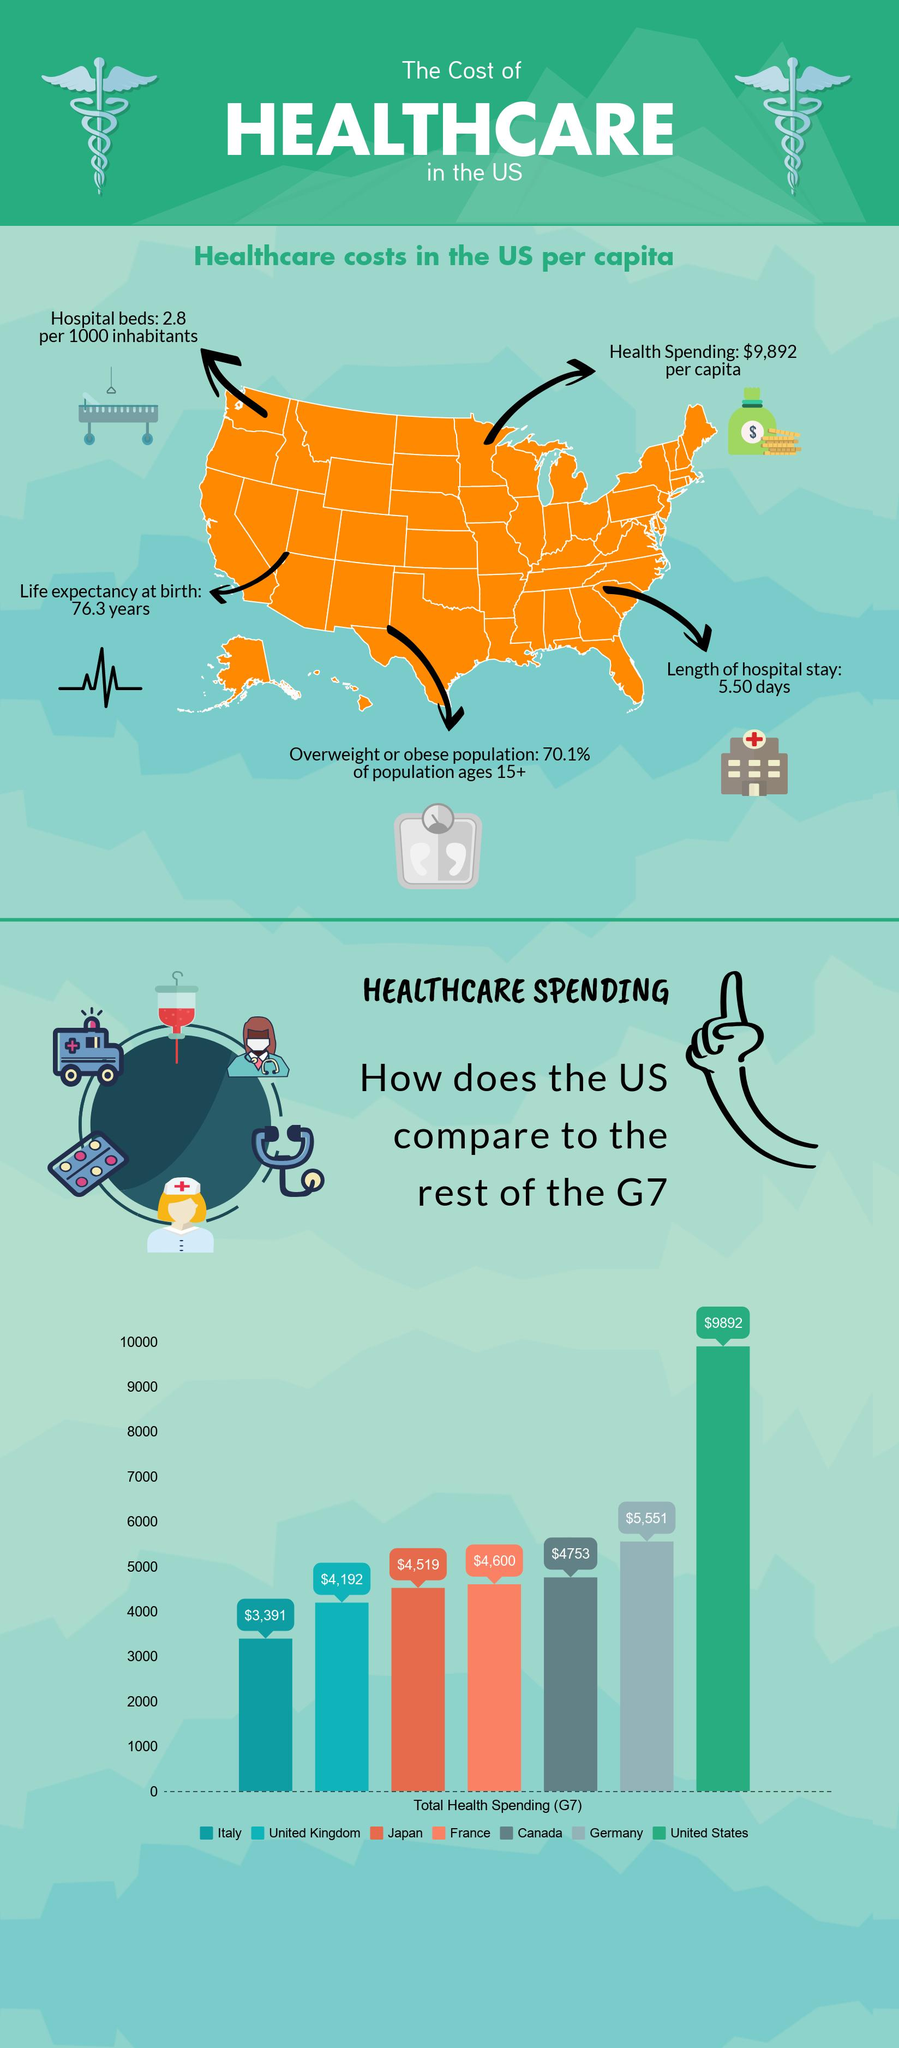Draw attention to some important aspects in this diagram. The United Kingdom spends more on healthcare than Italy. The amount that Japan spends on healthcare is $4,519. According to the data provided, the combined spending on healthcare by France and Canada is $9,353. 